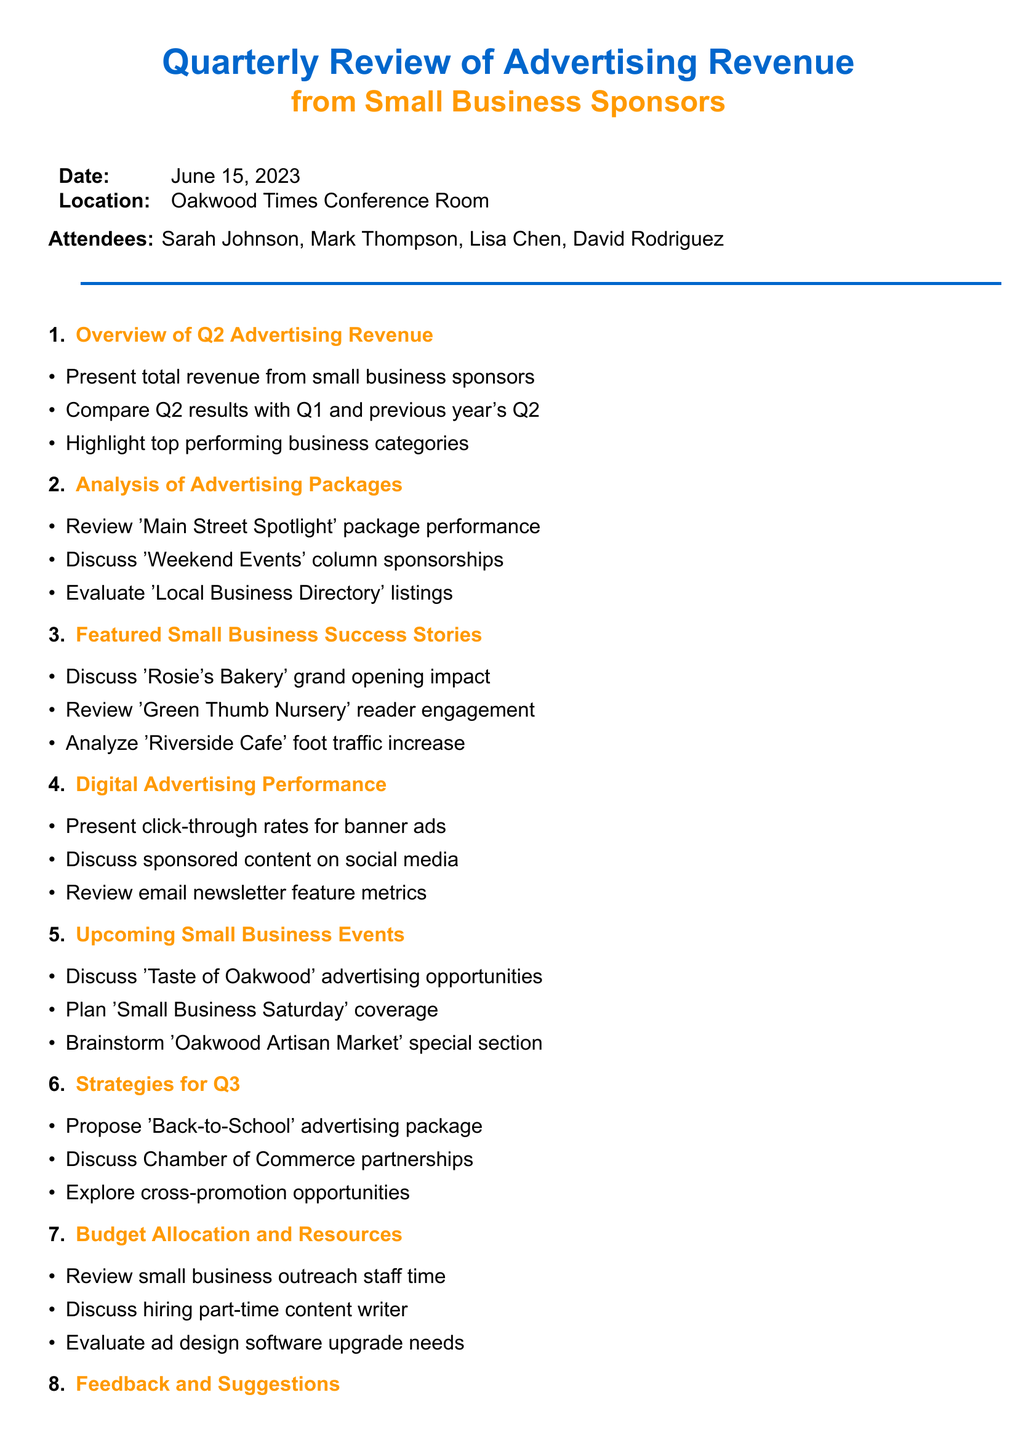What is the date of the meeting? The date of the meeting is explicitly stated in the document as June 15, 2023.
Answer: June 15, 2023 Who is the Advertising Manager? The document lists the attendees, including their roles, identifying Mark Thompson as the Advertising Manager.
Answer: Mark Thompson What is one of the top performing business categories? The agenda item outlines various performing categories, suggesting that restaurants are among them as an example.
Answer: Restaurants What is one action item mentioned? The action items are clearly listed in the document; one is preparing the Q3 advertising rate card.
Answer: Prepare Q3 advertising rate card for small businesses How many attendees are listed? The document states the names of the attendees; there are four attendees mentioned.
Answer: Four What is the title of the agenda item regarding success stories? The title of the relevant agenda item is explicitly stated as "Featured Small Business Success Stories."
Answer: Featured Small Business Success Stories What strategy is proposed for Q3? The document indicates a new 'Back-to-School' advertising package as a proposed strategy for Q3.
Answer: Back-to-School advertising package What event is mentioned for advertising opportunities? The agenda discusses advertising opportunities related to an annual event, specifically the 'Taste of Oakwood' food festival.
Answer: Taste of Oakwood What feedback is reviewed in the meeting? The document notes that survey results from small business advertisers are part of the feedback discussed.
Answer: Survey results from small business advertisers 